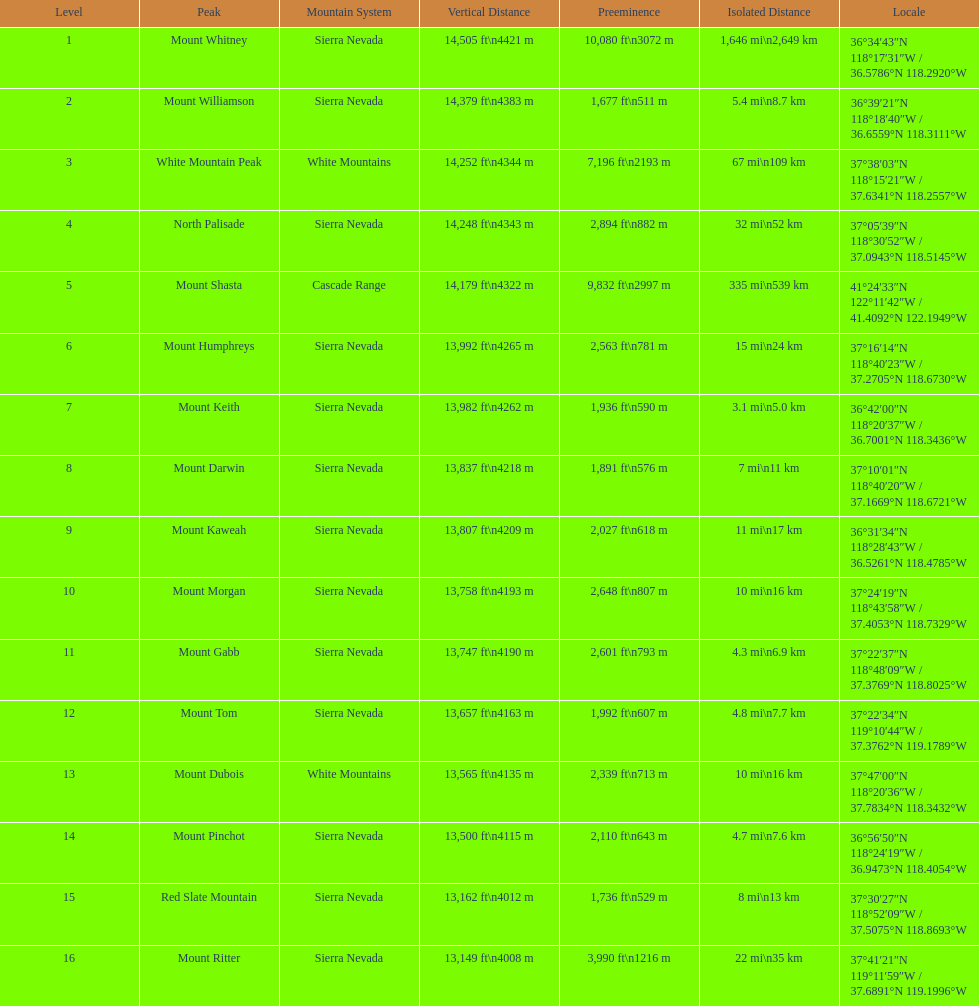What is the only mountain peak listed for the cascade range? Mount Shasta. 